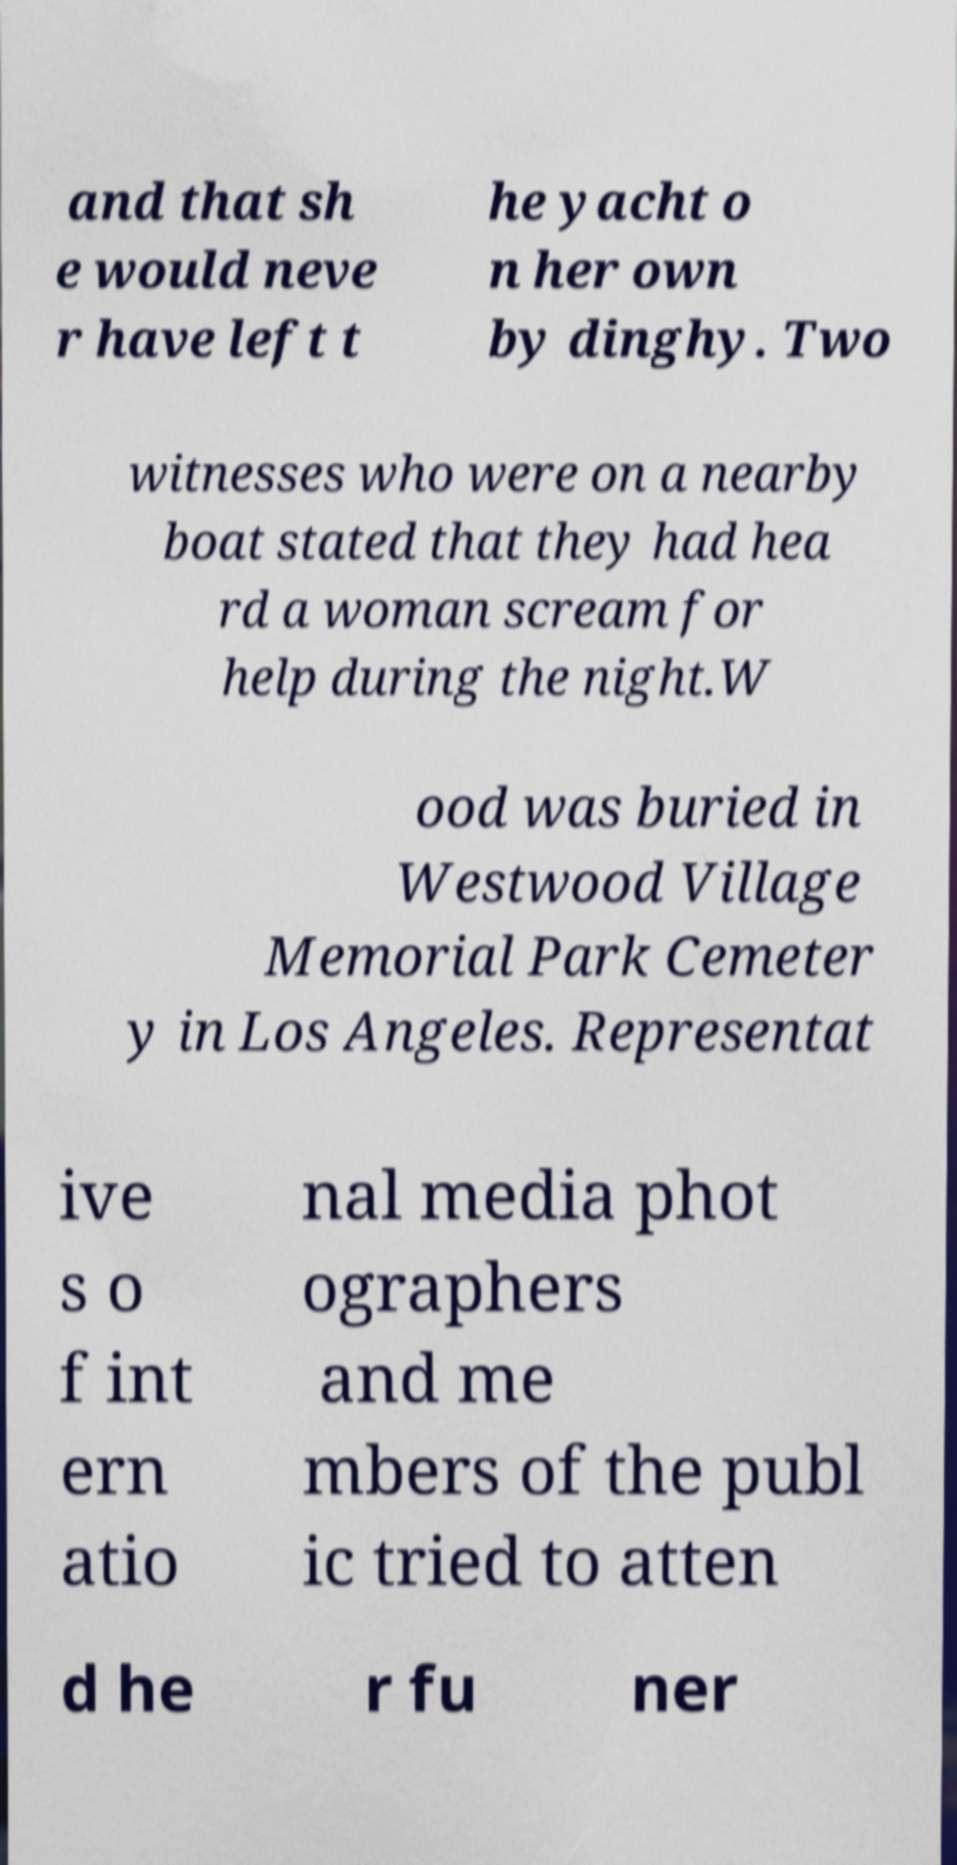Please read and relay the text visible in this image. What does it say? and that sh e would neve r have left t he yacht o n her own by dinghy. Two witnesses who were on a nearby boat stated that they had hea rd a woman scream for help during the night.W ood was buried in Westwood Village Memorial Park Cemeter y in Los Angeles. Representat ive s o f int ern atio nal media phot ographers and me mbers of the publ ic tried to atten d he r fu ner 